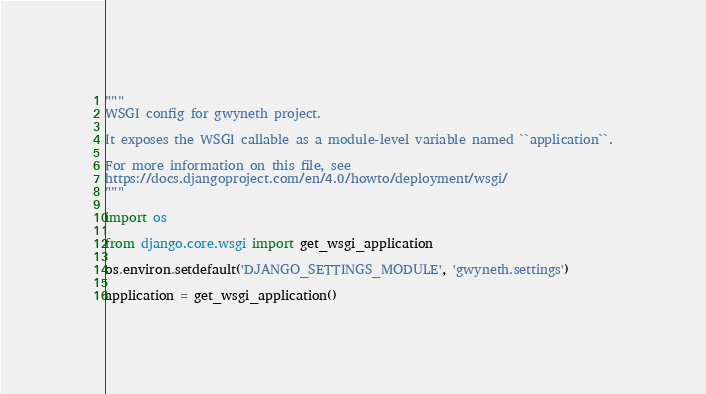Convert code to text. <code><loc_0><loc_0><loc_500><loc_500><_Python_>"""
WSGI config for gwyneth project.

It exposes the WSGI callable as a module-level variable named ``application``.

For more information on this file, see
https://docs.djangoproject.com/en/4.0/howto/deployment/wsgi/
"""

import os

from django.core.wsgi import get_wsgi_application

os.environ.setdefault('DJANGO_SETTINGS_MODULE', 'gwyneth.settings')

application = get_wsgi_application()
</code> 